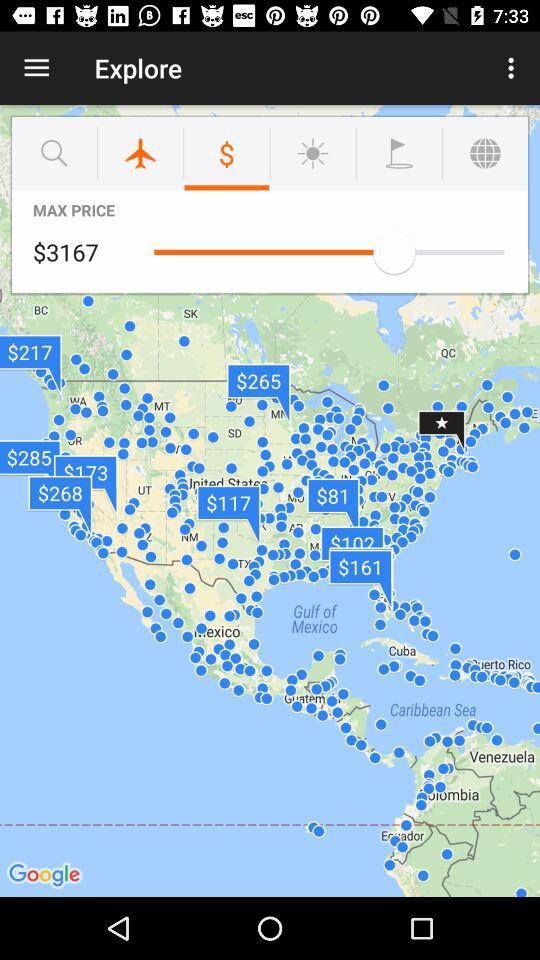What currency is the price in? The price is in dollars. 